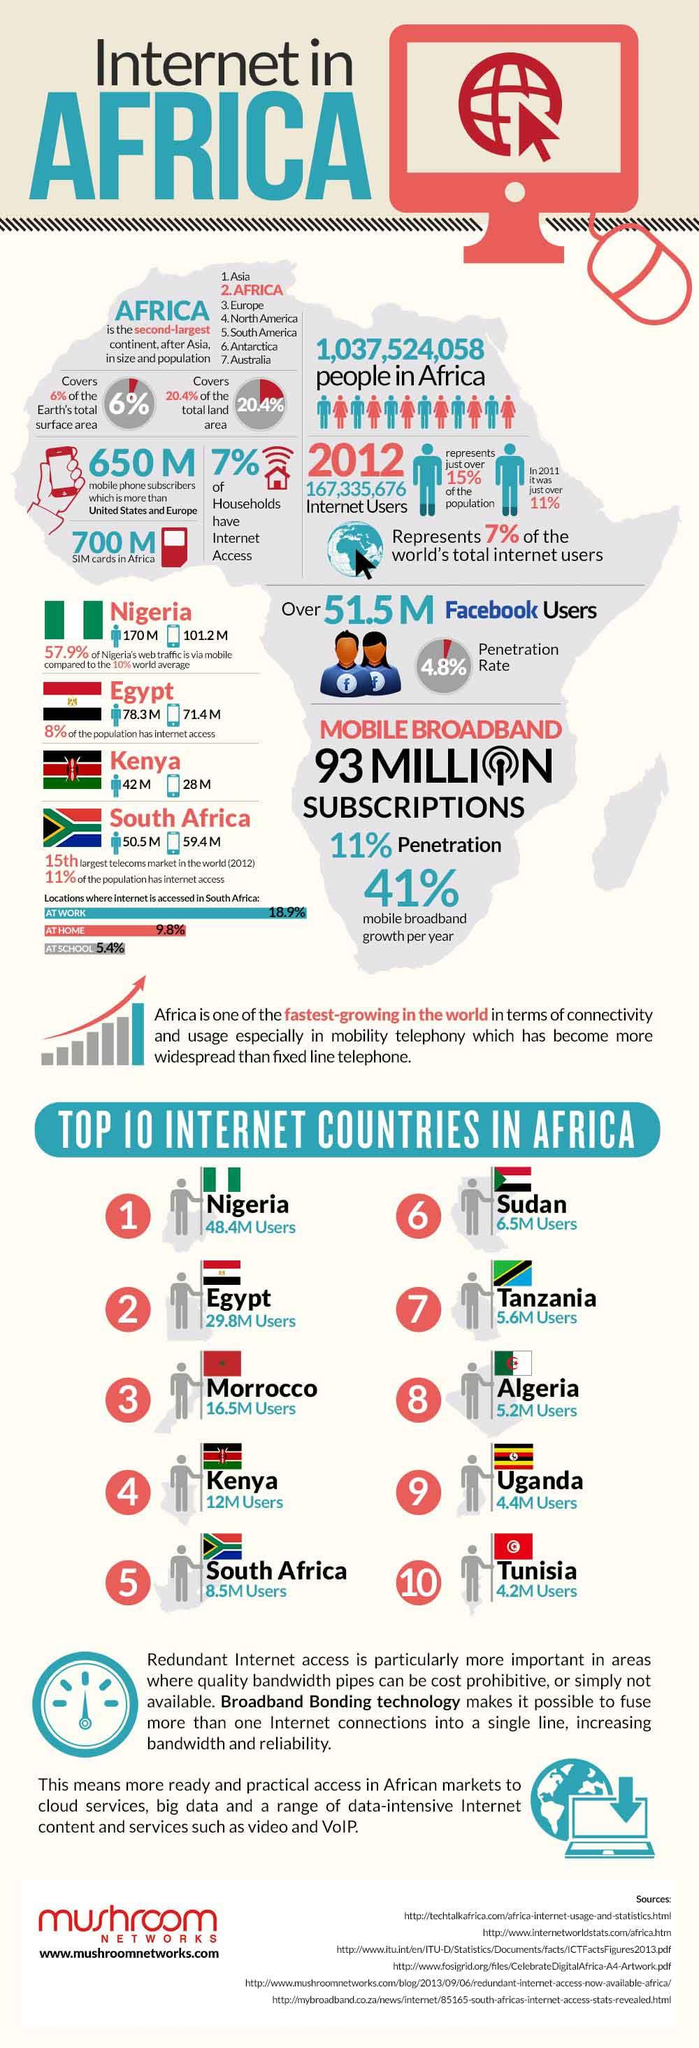List a handful of essential elements in this visual. In 2012, Morocco had the third highest number of internet users among the top African countries. In 2012, only 7% of households in Africa had access to the internet. In 2012, the number of internet users in Uganda was approximately 4.4 million. In 2012, it is estimated that there were approximately 700 million SIM cards available in Africa. In 2012, approximately 101.2 million people in Nigeria accessed the internet through their mobile devices. 